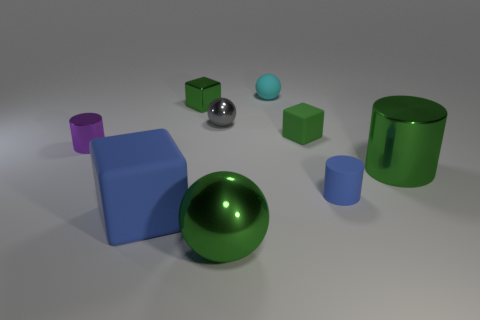What is the material of the big object that is to the left of the small cube left of the rubber block that is behind the big rubber cube?
Make the answer very short. Rubber. Is there a blue matte thing that has the same shape as the tiny purple metal object?
Make the answer very short. Yes. What shape is the gray shiny object that is the same size as the matte sphere?
Your answer should be very brief. Sphere. How many cubes are in front of the tiny shiny block and right of the big cube?
Provide a short and direct response. 1. Is the number of small cylinders that are left of the green metal cube less than the number of big green metal spheres?
Provide a short and direct response. No. Are there any green metal blocks of the same size as the green matte thing?
Ensure brevity in your answer.  Yes. There is a small sphere that is made of the same material as the large cylinder; what is its color?
Your response must be concise. Gray. How many small blocks are in front of the green shiny object that is to the left of the small gray ball?
Make the answer very short. 1. What material is the green object that is both to the right of the tiny gray object and behind the small purple cylinder?
Your response must be concise. Rubber. There is a blue thing on the right side of the big matte object; does it have the same shape as the small purple thing?
Provide a short and direct response. Yes. 